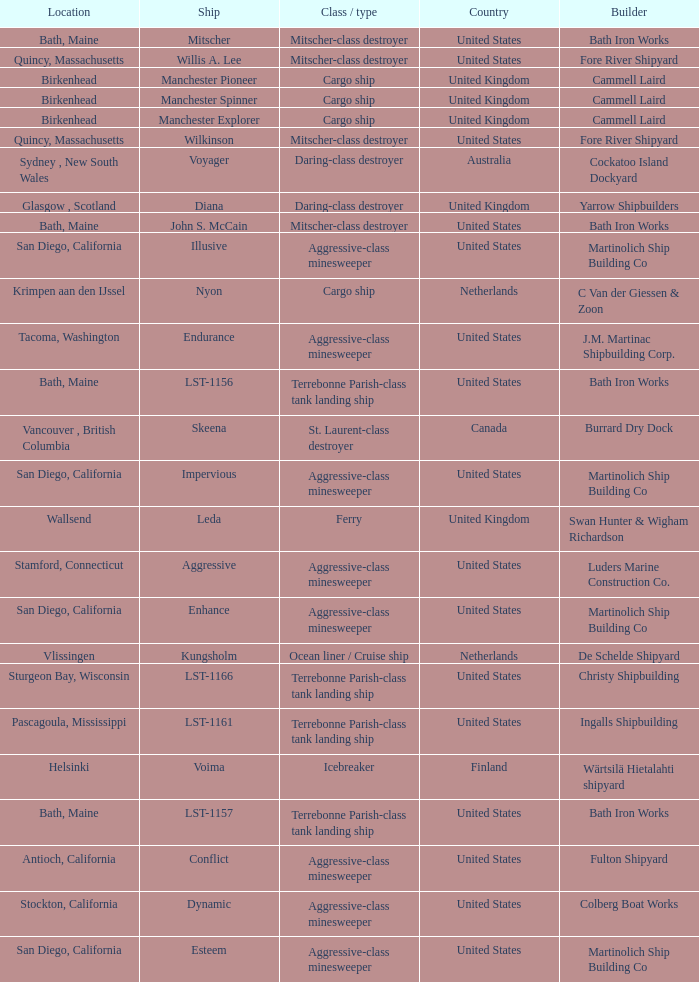What Ship was Built by Cammell Laird? Manchester Pioneer, Manchester Spinner, Manchester Explorer. 